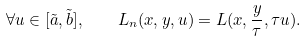Convert formula to latex. <formula><loc_0><loc_0><loc_500><loc_500>\forall u \in [ \tilde { a } , \tilde { b } ] , \quad L _ { n } ( x , y , u ) = L ( x , \frac { y } { \tau } , \tau u ) .</formula> 